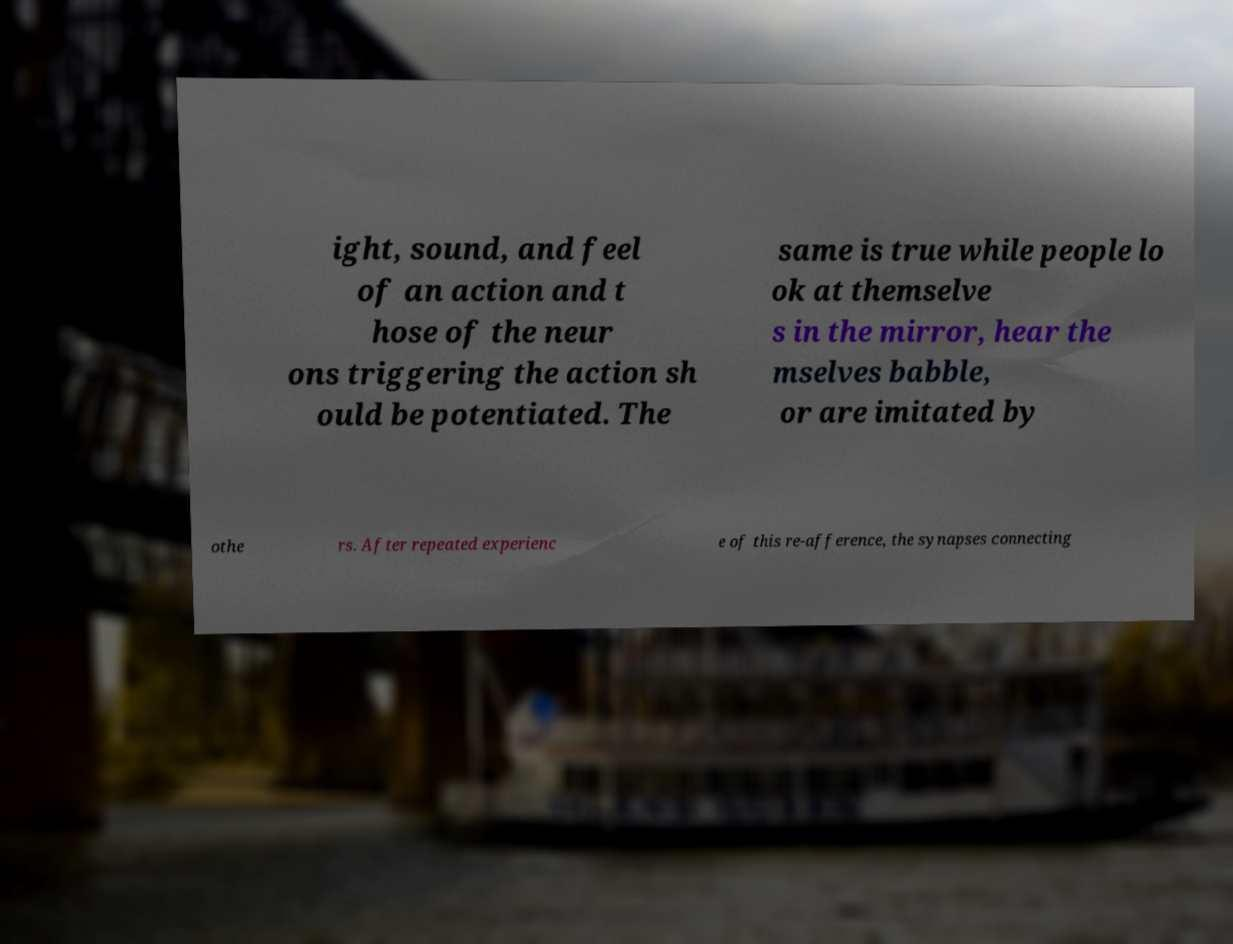Please identify and transcribe the text found in this image. ight, sound, and feel of an action and t hose of the neur ons triggering the action sh ould be potentiated. The same is true while people lo ok at themselve s in the mirror, hear the mselves babble, or are imitated by othe rs. After repeated experienc e of this re-afference, the synapses connecting 